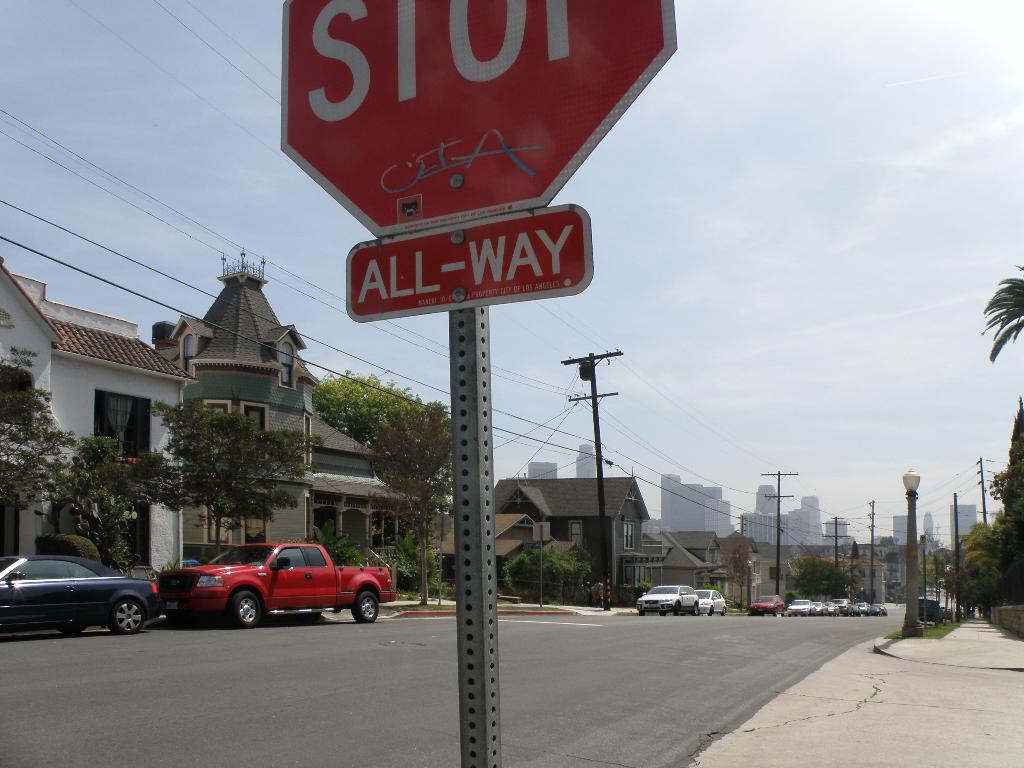What kind of way?
Your response must be concise. All-way. What are cars supposed to do when they approach this sign?
Your answer should be compact. Stop. 